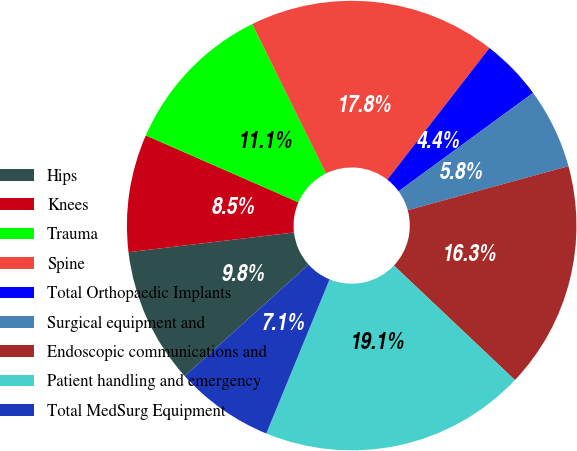<chart> <loc_0><loc_0><loc_500><loc_500><pie_chart><fcel>Hips<fcel>Knees<fcel>Trauma<fcel>Spine<fcel>Total Orthopaedic Implants<fcel>Surgical equipment and<fcel>Endoscopic communications and<fcel>Patient handling and emergency<fcel>Total MedSurg Equipment<nl><fcel>9.79%<fcel>8.46%<fcel>11.13%<fcel>17.8%<fcel>4.45%<fcel>5.79%<fcel>16.32%<fcel>19.14%<fcel>7.12%<nl></chart> 